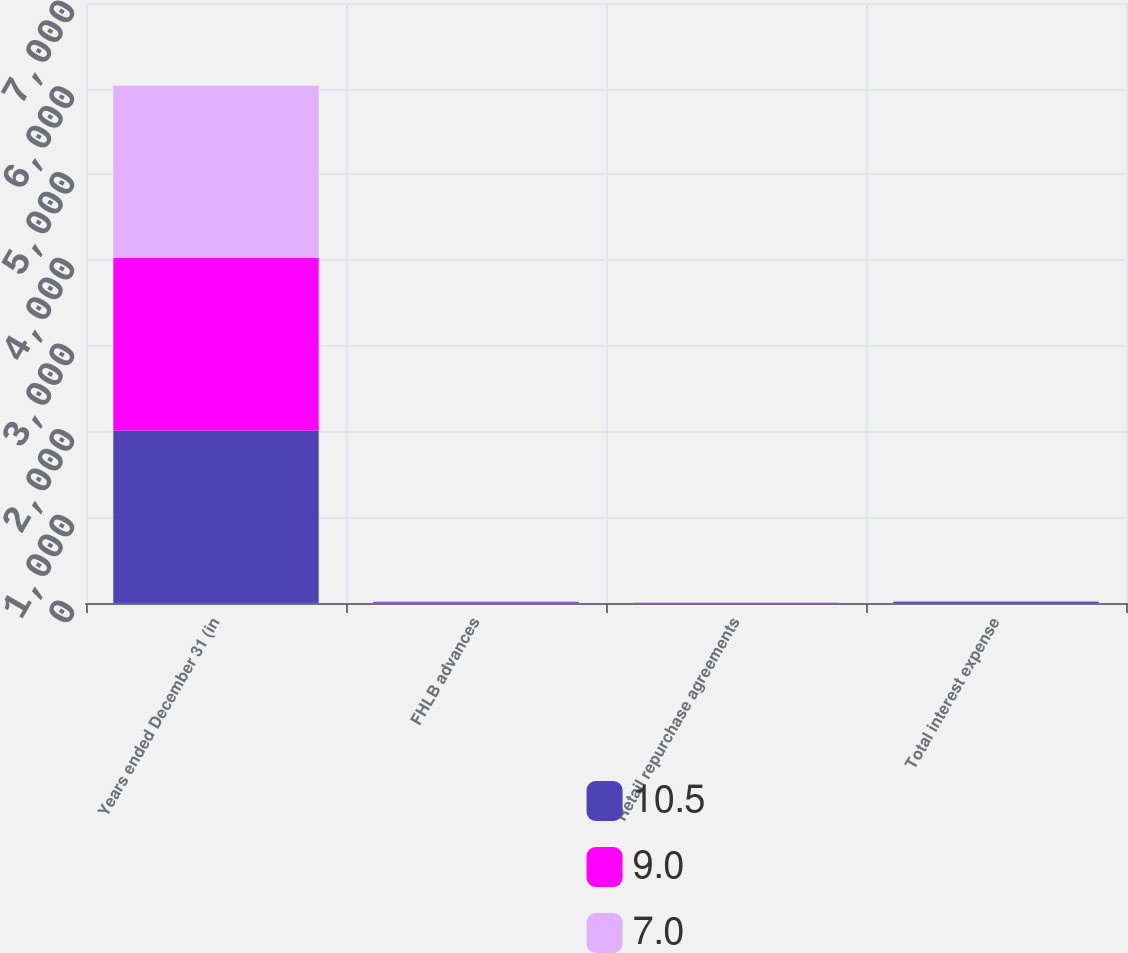Convert chart. <chart><loc_0><loc_0><loc_500><loc_500><stacked_bar_chart><ecel><fcel>Years ended December 31 (in<fcel>FHLB advances<fcel>Retail repurchase agreements<fcel>Total interest expense<nl><fcel>10.5<fcel>2013<fcel>8.2<fcel>1.1<fcel>10.5<nl><fcel>9<fcel>2012<fcel>5.1<fcel>1.3<fcel>7<nl><fcel>7<fcel>2011<fcel>6.7<fcel>2<fcel>9<nl></chart> 